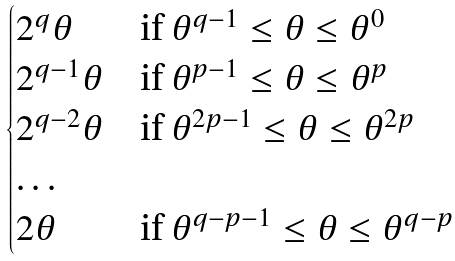Convert formula to latex. <formula><loc_0><loc_0><loc_500><loc_500>\begin{cases} 2 ^ { q } \theta & \text {if $\theta^{q-1} \leq\theta \leq \theta^{0}$} \\ 2 ^ { q - 1 } \theta & \text {if $\theta^{p-1} \leq\theta \leq \theta^{p}$} \\ 2 ^ { q - 2 } \theta & \text {if $\theta^{2p-1} \leq\theta \leq \theta^{2p}$} \\ \dots & \\ 2 \theta & \text {if $\theta^{q-p-1} \leq\theta \leq \theta^{q-p}$} \end{cases}</formula> 